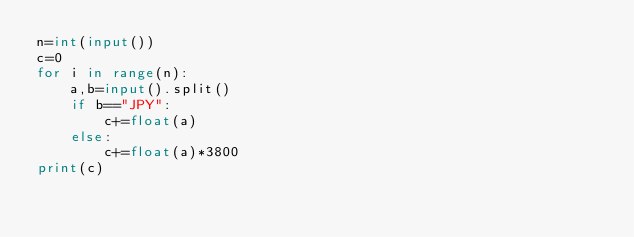<code> <loc_0><loc_0><loc_500><loc_500><_Python_>n=int(input())
c=0
for i in range(n):
    a,b=input().split()
    if b=="JPY":
        c+=float(a)
    else:
        c+=float(a)*3800
print(c)</code> 